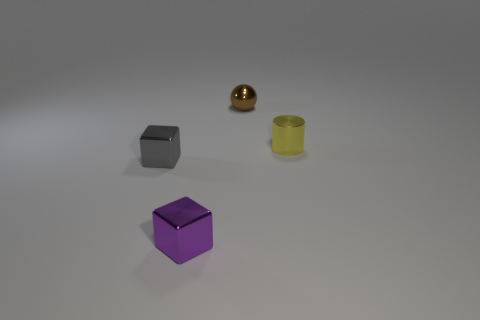What number of cyan objects are either shiny objects or tiny cylinders?
Ensure brevity in your answer.  0. Are there more metallic objects than brown metallic cylinders?
Your response must be concise. Yes. There is a metallic sphere that is the same size as the yellow metal object; what is its color?
Keep it short and to the point. Brown. How many cylinders are big cyan things or tiny brown things?
Your response must be concise. 0. Do the yellow shiny thing and the object that is behind the tiny yellow metal cylinder have the same shape?
Your response must be concise. No. How many metal cubes are the same size as the yellow object?
Your answer should be very brief. 2. Does the object that is in front of the small gray object have the same shape as the object left of the purple shiny block?
Your answer should be very brief. Yes. There is a tiny shiny object to the left of the metal cube in front of the gray thing; what is its color?
Your answer should be compact. Gray. The other thing that is the same shape as the gray metal object is what color?
Offer a very short reply. Purple. Is there anything else that is the same material as the small brown object?
Your response must be concise. Yes. 